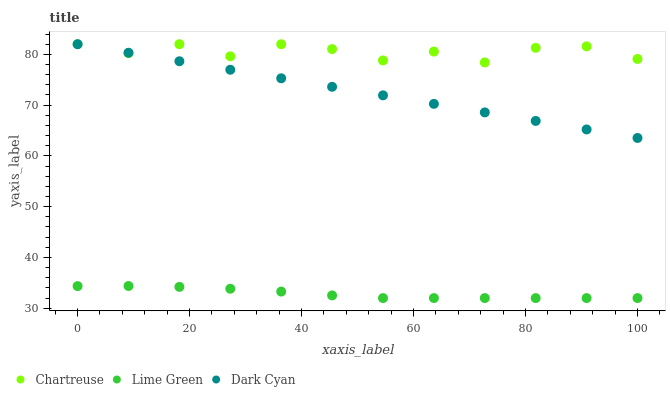Does Lime Green have the minimum area under the curve?
Answer yes or no. Yes. Does Chartreuse have the maximum area under the curve?
Answer yes or no. Yes. Does Chartreuse have the minimum area under the curve?
Answer yes or no. No. Does Lime Green have the maximum area under the curve?
Answer yes or no. No. Is Dark Cyan the smoothest?
Answer yes or no. Yes. Is Chartreuse the roughest?
Answer yes or no. Yes. Is Lime Green the smoothest?
Answer yes or no. No. Is Lime Green the roughest?
Answer yes or no. No. Does Lime Green have the lowest value?
Answer yes or no. Yes. Does Chartreuse have the lowest value?
Answer yes or no. No. Does Chartreuse have the highest value?
Answer yes or no. Yes. Does Lime Green have the highest value?
Answer yes or no. No. Is Lime Green less than Dark Cyan?
Answer yes or no. Yes. Is Chartreuse greater than Lime Green?
Answer yes or no. Yes. Does Dark Cyan intersect Chartreuse?
Answer yes or no. Yes. Is Dark Cyan less than Chartreuse?
Answer yes or no. No. Is Dark Cyan greater than Chartreuse?
Answer yes or no. No. Does Lime Green intersect Dark Cyan?
Answer yes or no. No. 